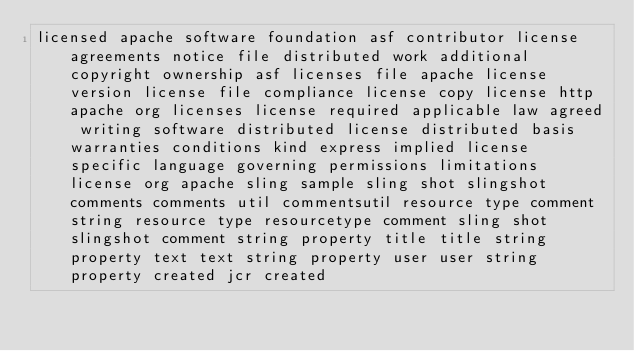<code> <loc_0><loc_0><loc_500><loc_500><_Java_>licensed apache software foundation asf contributor license agreements notice file distributed work additional copyright ownership asf licenses file apache license version license file compliance license copy license http apache org licenses license required applicable law agreed writing software distributed license distributed basis warranties conditions kind express implied license specific language governing permissions limitations license org apache sling sample sling shot slingshot comments comments util commentsutil resource type comment string resource type resourcetype comment sling shot slingshot comment string property title title string property text text string property user user string property created jcr created</code> 